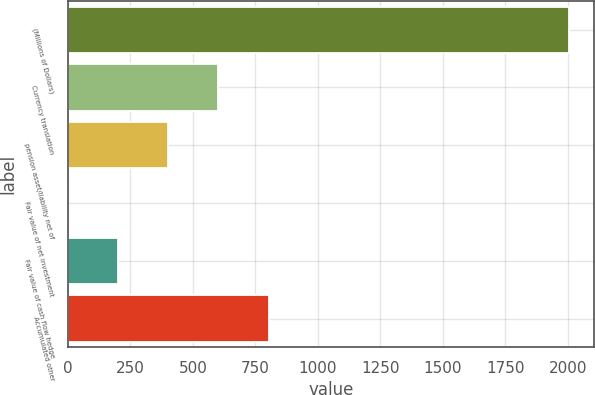<chart> <loc_0><loc_0><loc_500><loc_500><bar_chart><fcel>(Millions of Dollars)<fcel>Currency translation<fcel>pension asset/liability net of<fcel>Fair value of net investment<fcel>Fair value of cash flow hedge<fcel>Accumulated other<nl><fcel>2005<fcel>601.85<fcel>401.4<fcel>0.5<fcel>200.95<fcel>802.3<nl></chart> 